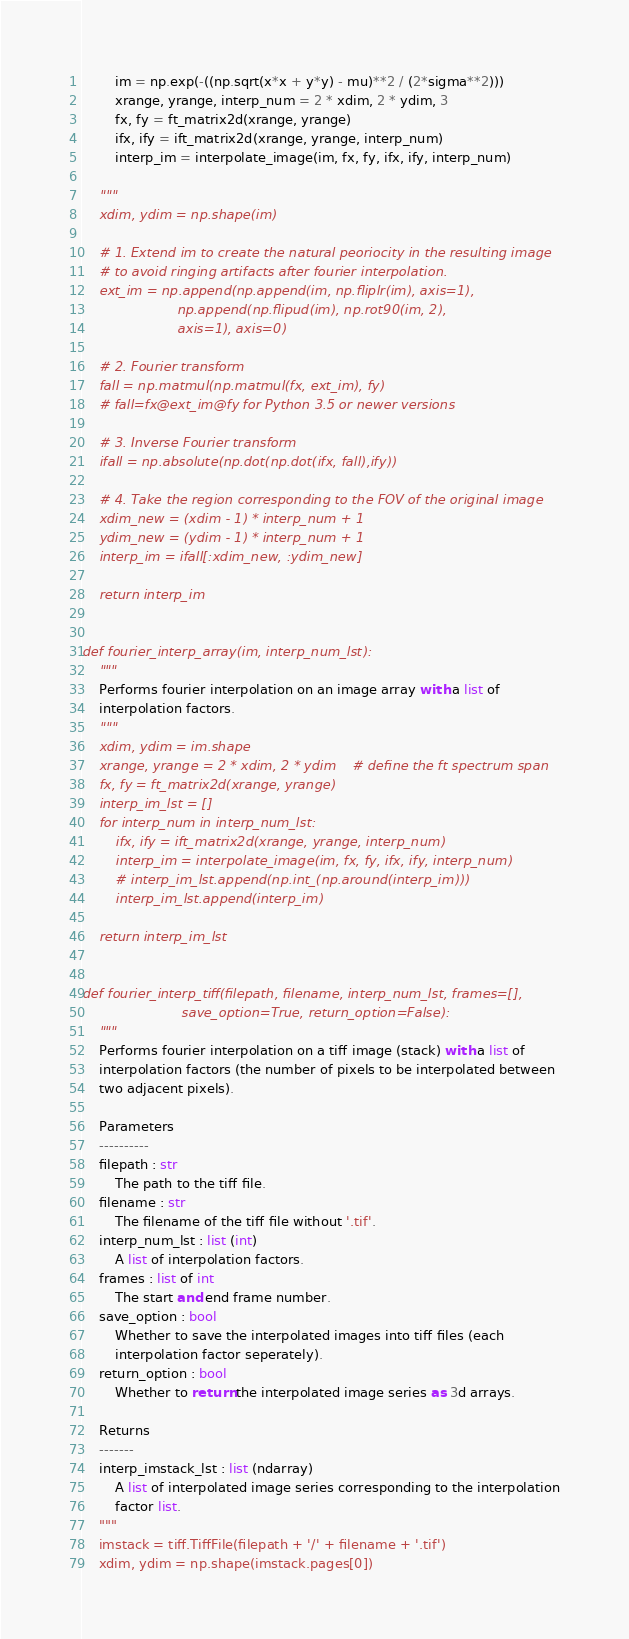<code> <loc_0><loc_0><loc_500><loc_500><_Python_>        im = np.exp(-((np.sqrt(x*x + y*y) - mu)**2 / (2*sigma**2)))
        xrange, yrange, interp_num = 2 * xdim, 2 * ydim, 3
        fx, fy = ft_matrix2d(xrange, yrange)
        ifx, ify = ift_matrix2d(xrange, yrange, interp_num)
        interp_im = interpolate_image(im, fx, fy, ifx, ify, interp_num)

    """
    xdim, ydim = np.shape(im)

    # 1. Extend im to create the natural peoriocity in the resulting image 
    # to avoid ringing artifacts after fourier interpolation.
    ext_im = np.append(np.append(im, np.fliplr(im), axis=1), 
                       np.append(np.flipud(im), np.rot90(im, 2), 
                       axis=1), axis=0)

    # 2. Fourier transform
    fall = np.matmul(np.matmul(fx, ext_im), fy)     
    # fall=fx@ext_im@fy for Python 3.5 or newer versions

    # 3. Inverse Fourier transform
    ifall = np.absolute(np.dot(np.dot(ifx, fall),ify))

    # 4. Take the region corresponding to the FOV of the original image
    xdim_new = (xdim - 1) * interp_num + 1
    ydim_new = (ydim - 1) * interp_num + 1
    interp_im = ifall[:xdim_new, :ydim_new]
    
    return interp_im


def fourier_interp_array(im, interp_num_lst):
    """
    Performs fourier interpolation on an image array with a list of 
    interpolation factors.
    """
    xdim, ydim = im.shape
    xrange, yrange = 2 * xdim, 2 * ydim    # define the ft spectrum span
    fx, fy = ft_matrix2d(xrange, yrange)
    interp_im_lst = []
    for interp_num in interp_num_lst:
        ifx, ify = ift_matrix2d(xrange, yrange, interp_num)
        interp_im = interpolate_image(im, fx, fy, ifx, ify, interp_num)       
        # interp_im_lst.append(np.int_(np.around(interp_im)))
        interp_im_lst.append(interp_im)
            
    return interp_im_lst


def fourier_interp_tiff(filepath, filename, interp_num_lst, frames=[],
                        save_option=True, return_option=False):
    """
    Performs fourier interpolation on a tiff image (stack) with a list of 
    interpolation factors (the number of pixels to be interpolated between 
    two adjacent pixels).

    Parameters
    ----------
    filepath : str
        The path to the tiff file.
    filename : str
        The filename of the tiff file without '.tif'.
    interp_num_lst : list (int)
        A list of interpolation factors.
    frames : list of int
        The start and end frame number.
    save_option : bool
        Whether to save the interpolated images into tiff files (each 
        interpolation factor seperately).
    return_option : bool
        Whether to return the interpolated image series as 3d arrays.

    Returns
    -------
    interp_imstack_lst : list (ndarray)
        A list of interpolated image series corresponding to the interpolation
        factor list.
    """
    imstack = tiff.TiffFile(filepath + '/' + filename + '.tif')
    xdim, ydim = np.shape(imstack.pages[0])</code> 